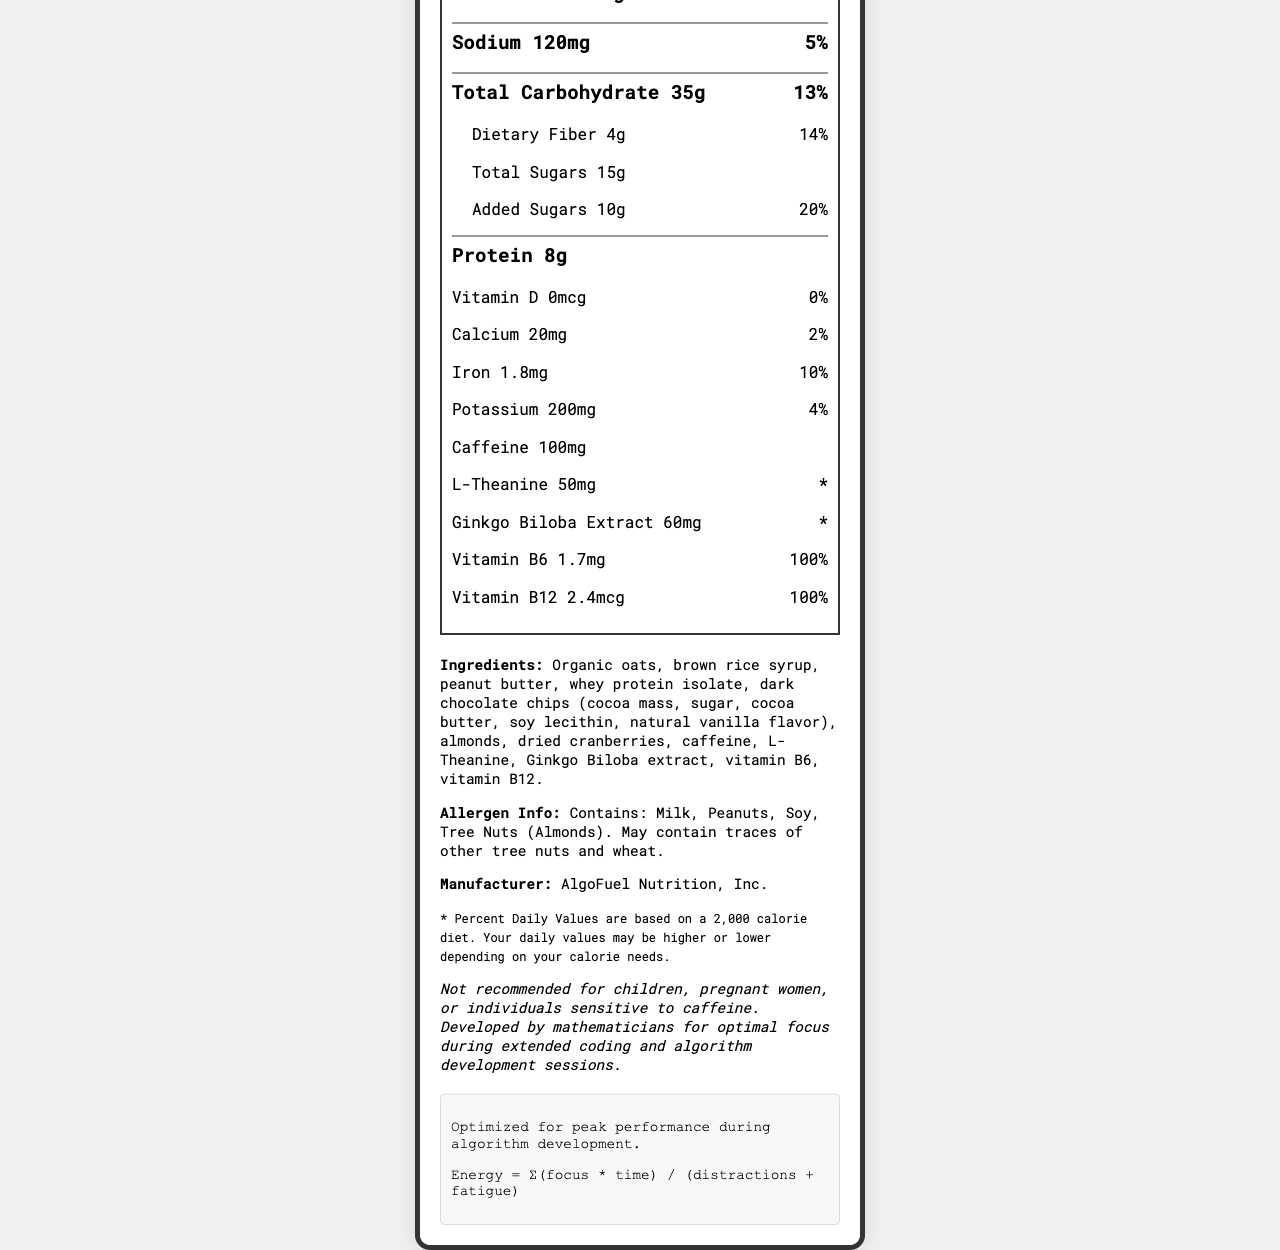what is the serving size of the CodeCrunch Energy Bar? The serving size is directly mentioned in the document under the "Nutrition Facts" heading.
Answer: 1 bar (60g) how many calories are in one serving of the CodeCrunch Energy Bar? The calorie content per serving is listed as 250 under the "Nutrition Facts" section.
Answer: 250 what amount of caffeine is in one serving of the CodeCrunch Energy Bar? The amount of caffeine is clearly mentioned towards the end of the "Nutrition Facts" section.
Answer: 100mg what is the percentage daily value of iron in one serving? The daily value percentage for iron is listed as 10% in the document.
Answer: 10% how many grams of protein does one CodeCrunch Energy Bar contain? The protein content in the energy bar is noted as 8g under the "Nutrition Facts".
Answer: 8g what are the additional nutrients included in the CodeCrunch Energy Bar? A. L-Theanine, Vitamin C, Magnesium B. L-Theanine, Ginkgo Biloba Extract, Vitamin B6, Vitamin B12 C. Ginkgo Biloba Extract, Omega-3, Calcium, Vitamin D The additional nutrients listed are L-Theanine, Ginkgo Biloba Extract, Vitamin B6 and Vitamin B12.
Answer: B how many servings per container of the CodeCrunch Energy Bar? A. 2 B. 4 C. 6 D. 8 The number of servings per container is listed as 6 under the "Nutrition Facts".
Answer: C does the CodeCrunch Energy Bar contain any trans fat? The document explicitly states that the trans fat content is 0g.
Answer: No is the CodeCrunch Energy Bar recommended for children? The additional information states that it is not recommended for children, pregnant women, or individuals sensitive to caffeine.
Answer: No describe the main purpose of the CodeCrunch Energy Bar. The document mentions that it is developed by mathematicians for optimal focus during extended coding and algorithm development sessions.
Answer: The CodeCrunch Energy Bar is designed to improve focus during long coding sessions. what is the primary sweetener in the CodeCrunch Energy Bar? The primary sweetener is not explicitly identified in the "Ingredients" list. It mentions several ingredients but does not clarify which is the primary sweetener.
Answer: Cannot be determined 